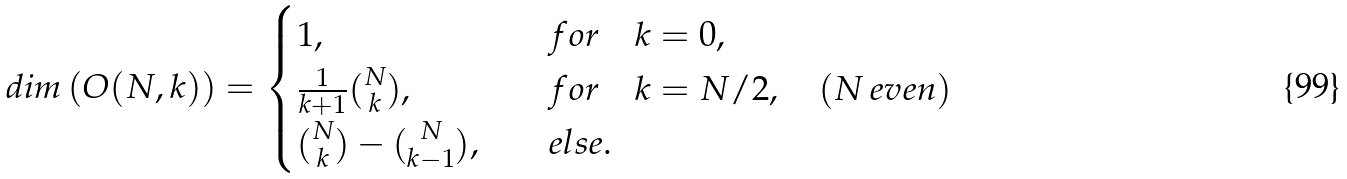<formula> <loc_0><loc_0><loc_500><loc_500>d i m \left ( O ( N , k ) \right ) = \begin{cases} 1 , \quad & f o r \quad k = 0 , \\ \frac { 1 } { k + 1 } { N \choose k } , \quad & f o r \quad k = N / 2 , \quad ( N \, e v e n ) \\ { N \choose k } - { N \choose k - 1 } , \quad & e l s e . \end{cases}</formula> 